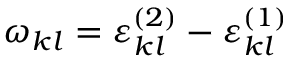Convert formula to latex. <formula><loc_0><loc_0><loc_500><loc_500>\omega _ { k l } = \varepsilon _ { k l } ^ { ( 2 ) } - \varepsilon _ { k l } ^ { ( 1 ) }</formula> 